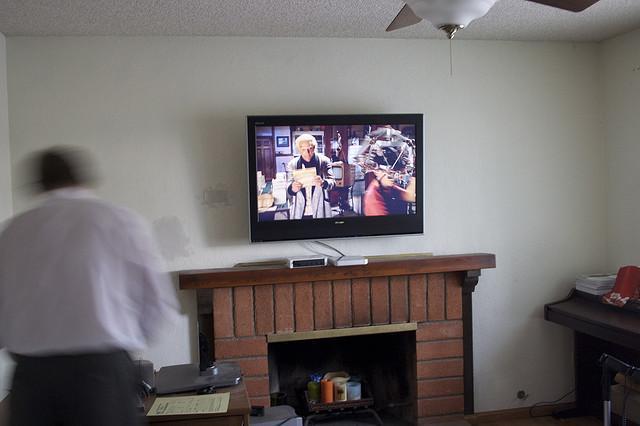How many animals are on the TV screen?
Give a very brief answer. 0. How many tvs are there?
Give a very brief answer. 1. How many elephants are there?
Give a very brief answer. 0. 